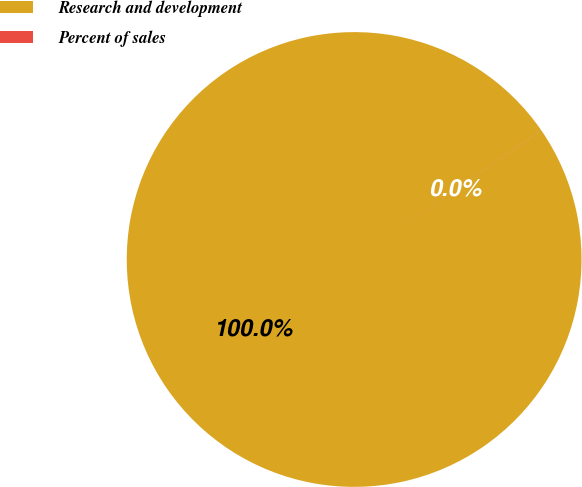<chart> <loc_0><loc_0><loc_500><loc_500><pie_chart><fcel>Research and development<fcel>Percent of sales<nl><fcel>99.99%<fcel>0.01%<nl></chart> 